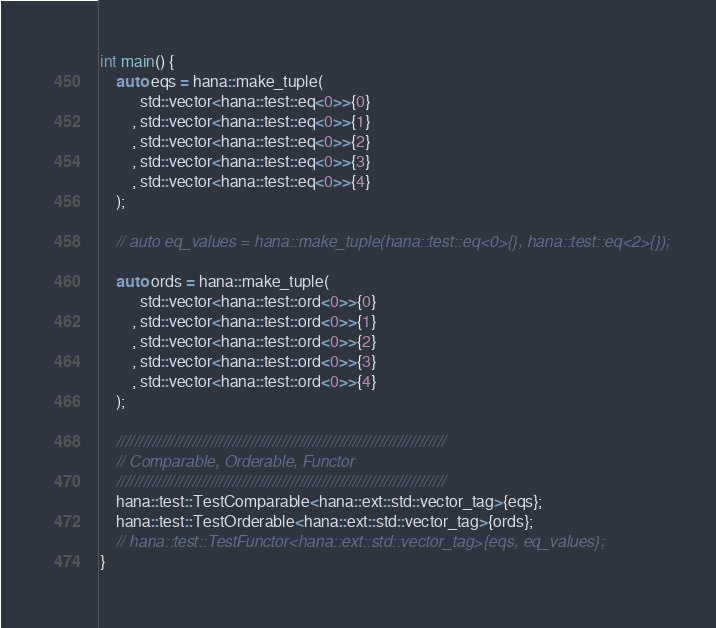Convert code to text. <code><loc_0><loc_0><loc_500><loc_500><_C++_>int main() {
    auto eqs = hana::make_tuple(
          std::vector<hana::test::eq<0>>{0}
        , std::vector<hana::test::eq<0>>{1}
        , std::vector<hana::test::eq<0>>{2}
        , std::vector<hana::test::eq<0>>{3}
        , std::vector<hana::test::eq<0>>{4}
    );

    // auto eq_values = hana::make_tuple(hana::test::eq<0>{}, hana::test::eq<2>{});

    auto ords = hana::make_tuple(
          std::vector<hana::test::ord<0>>{0}
        , std::vector<hana::test::ord<0>>{1}
        , std::vector<hana::test::ord<0>>{2}
        , std::vector<hana::test::ord<0>>{3}
        , std::vector<hana::test::ord<0>>{4}
    );

    //////////////////////////////////////////////////////////////////////////
    // Comparable, Orderable, Functor
    //////////////////////////////////////////////////////////////////////////
    hana::test::TestComparable<hana::ext::std::vector_tag>{eqs};
    hana::test::TestOrderable<hana::ext::std::vector_tag>{ords};
    // hana::test::TestFunctor<hana::ext::std::vector_tag>{eqs, eq_values};
}
</code> 